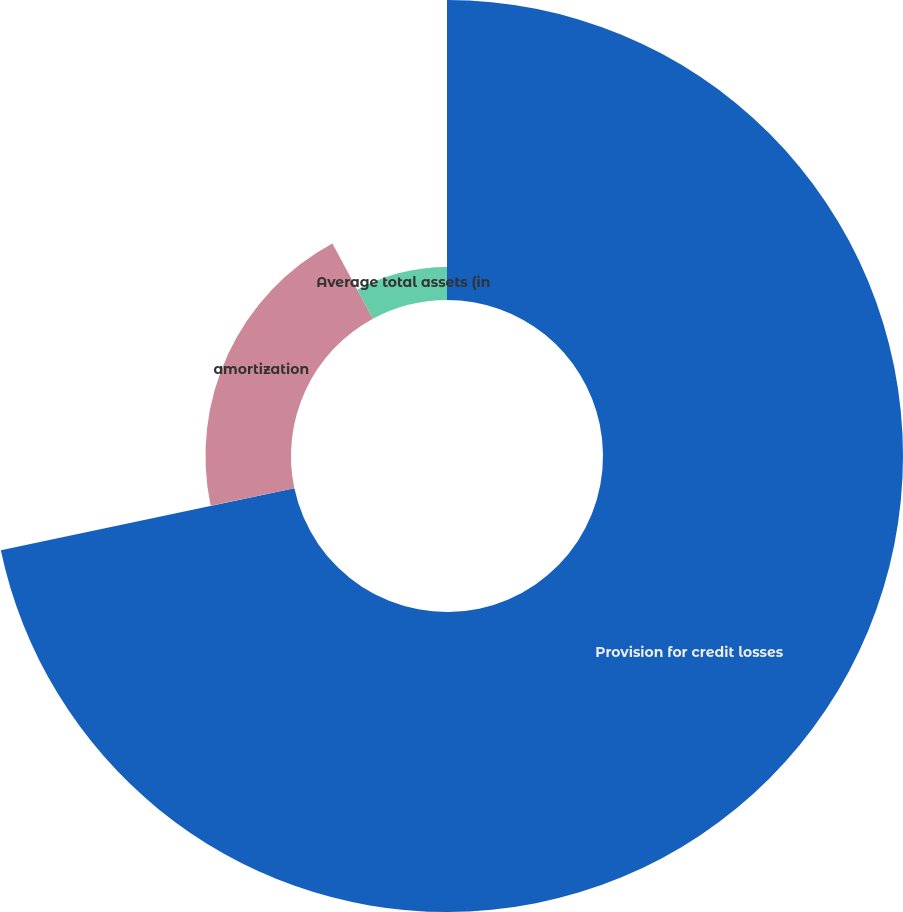Convert chart to OTSL. <chart><loc_0><loc_0><loc_500><loc_500><pie_chart><fcel>Provision for credit losses<fcel>amortization<fcel>Average total assets (in<nl><fcel>71.69%<fcel>20.44%<fcel>7.87%<nl></chart> 